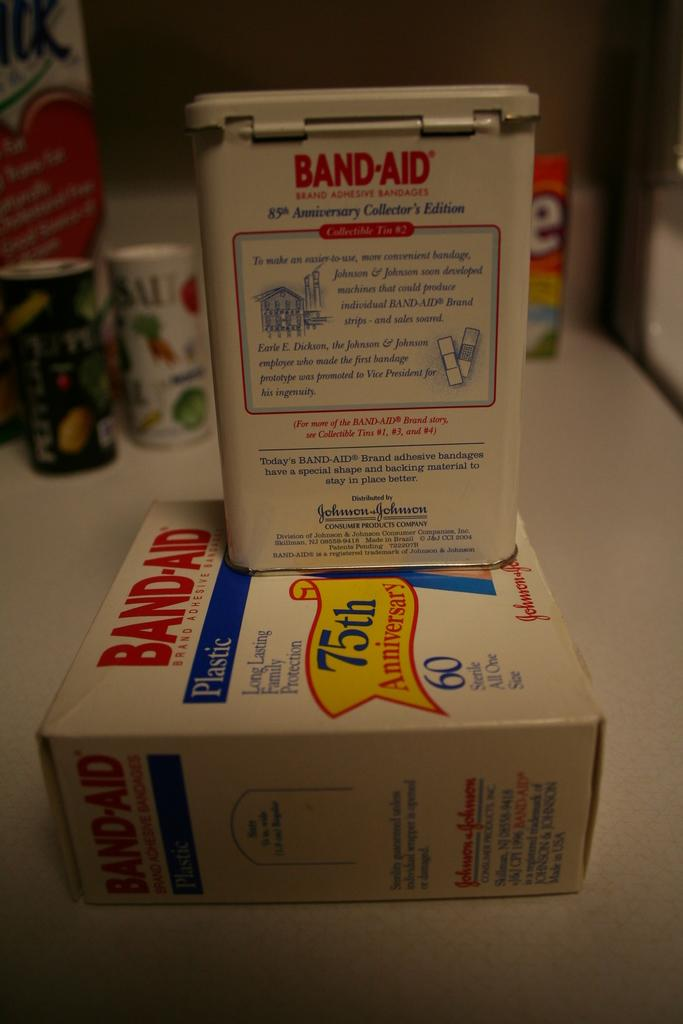What piece of furniture is present in the image? There is a table in the image. What is placed on the table? There is a carton and tins on the table. What type of lumber is being used to construct the table in the image? There is no information about the type of lumber used to construct the table in the image. 